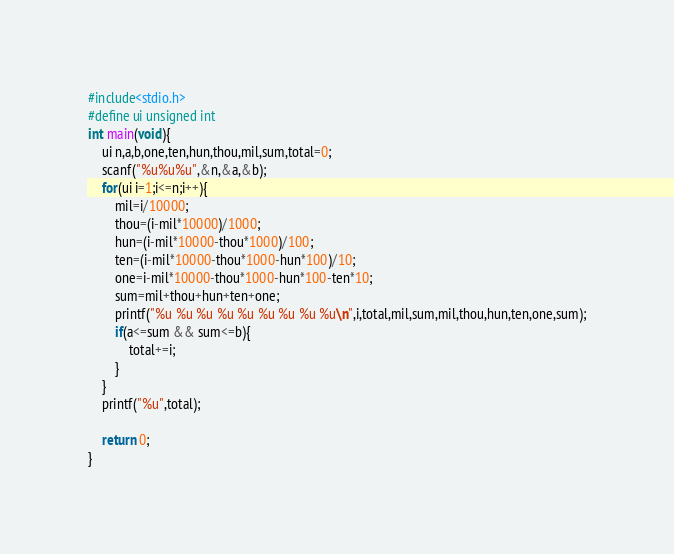<code> <loc_0><loc_0><loc_500><loc_500><_C_>#include<stdio.h>
#define ui unsigned int
int main(void){
	ui n,a,b,one,ten,hun,thou,mil,sum,total=0;
	scanf("%u%u%u",&n,&a,&b);
	for(ui i=1;i<=n;i++){
		mil=i/10000;
		thou=(i-mil*10000)/1000;
		hun=(i-mil*10000-thou*1000)/100;
		ten=(i-mil*10000-thou*1000-hun*100)/10;
		one=i-mil*10000-thou*1000-hun*100-ten*10;
		sum=mil+thou+hun+ten+one;
		printf("%u %u %u %u %u %u %u %u %u\n",i,total,mil,sum,mil,thou,hun,ten,one,sum);
		if(a<=sum && sum<=b){
			total+=i;
		}
	}
	printf("%u",total);

	return 0;
}
</code> 